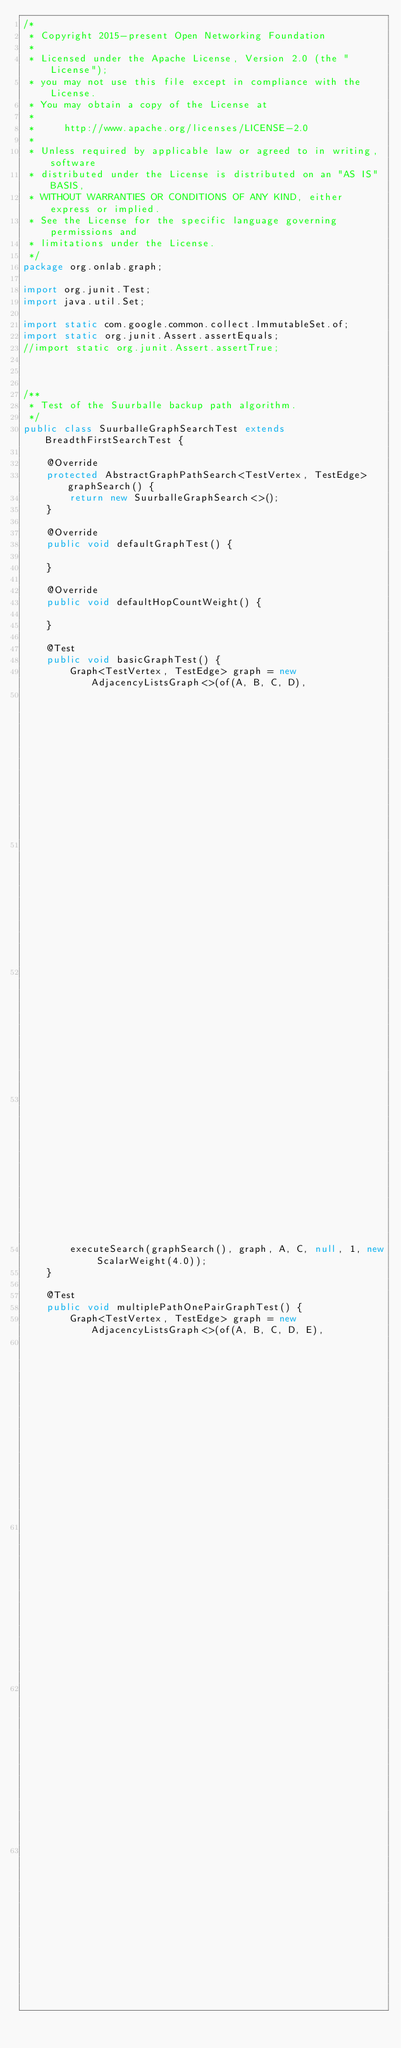<code> <loc_0><loc_0><loc_500><loc_500><_Java_>/*
 * Copyright 2015-present Open Networking Foundation
 *
 * Licensed under the Apache License, Version 2.0 (the "License");
 * you may not use this file except in compliance with the License.
 * You may obtain a copy of the License at
 *
 *     http://www.apache.org/licenses/LICENSE-2.0
 *
 * Unless required by applicable law or agreed to in writing, software
 * distributed under the License is distributed on an "AS IS" BASIS,
 * WITHOUT WARRANTIES OR CONDITIONS OF ANY KIND, either express or implied.
 * See the License for the specific language governing permissions and
 * limitations under the License.
 */
package org.onlab.graph;

import org.junit.Test;
import java.util.Set;

import static com.google.common.collect.ImmutableSet.of;
import static org.junit.Assert.assertEquals;
//import static org.junit.Assert.assertTrue;



/**
 * Test of the Suurballe backup path algorithm.
 */
public class SuurballeGraphSearchTest extends BreadthFirstSearchTest {

    @Override
    protected AbstractGraphPathSearch<TestVertex, TestEdge> graphSearch() {
        return new SuurballeGraphSearch<>();
    }

    @Override
    public void defaultGraphTest() {

    }

    @Override
    public void defaultHopCountWeight() {

    }

    @Test
    public void basicGraphTest() {
        Graph<TestVertex, TestEdge> graph = new AdjacencyListsGraph<>(of(A, B, C, D),
                                                                      of(new TestEdge(A, B),
                                                                         new TestEdge(B, C),
                                                                         new TestEdge(A, D),
                                                                         new TestEdge(D, C)));
        executeSearch(graphSearch(), graph, A, C, null, 1, new ScalarWeight(4.0));
    }

    @Test
    public void multiplePathOnePairGraphTest() {
        Graph<TestVertex, TestEdge> graph = new AdjacencyListsGraph<>(of(A, B, C, D, E),
                                                                      of(new TestEdge(A, B, W1),
                                                                         new TestEdge(B, C, W1),
                                                                         new TestEdge(A, D, W1),
                                                                         new TestEdge(D, C, W1),</code> 